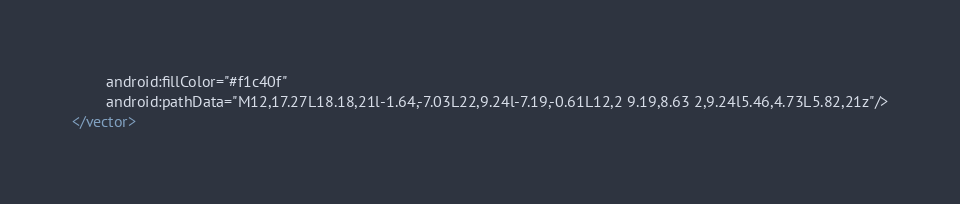<code> <loc_0><loc_0><loc_500><loc_500><_XML_>        android:fillColor="#f1c40f"
        android:pathData="M12,17.27L18.18,21l-1.64,-7.03L22,9.24l-7.19,-0.61L12,2 9.19,8.63 2,9.24l5.46,4.73L5.82,21z"/>
</vector>
</code> 